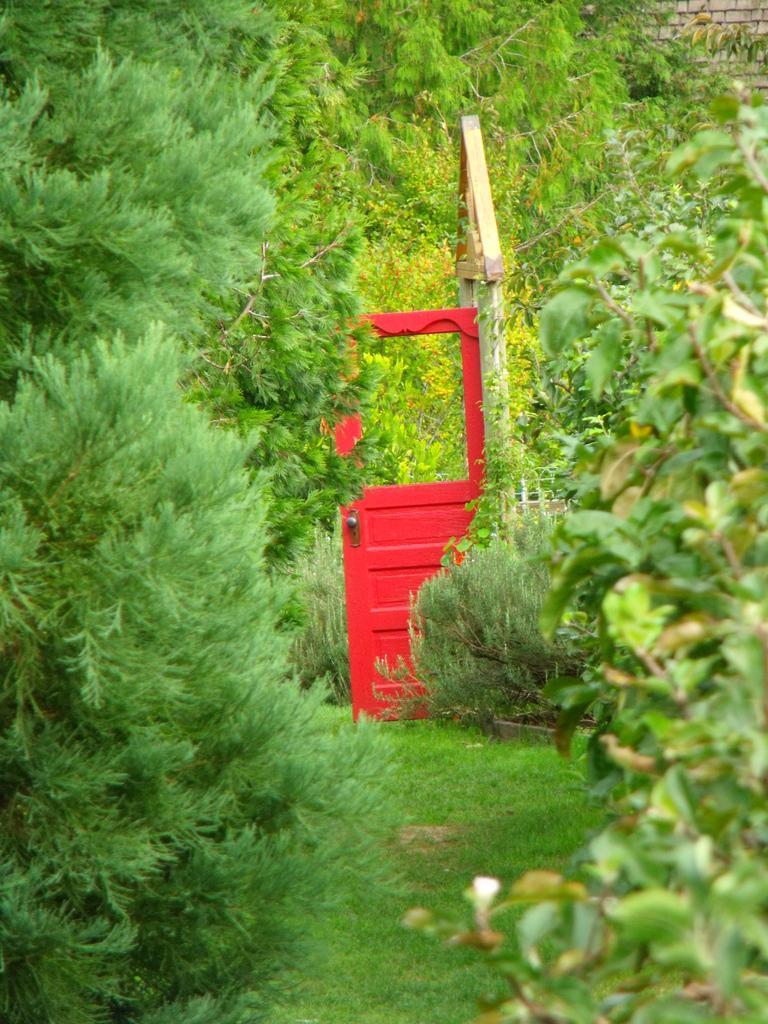How would you summarize this image in a sentence or two? In this picture I can observe some grass on the land. In the middle of the picture there is a red color door. In the background there are trees. 